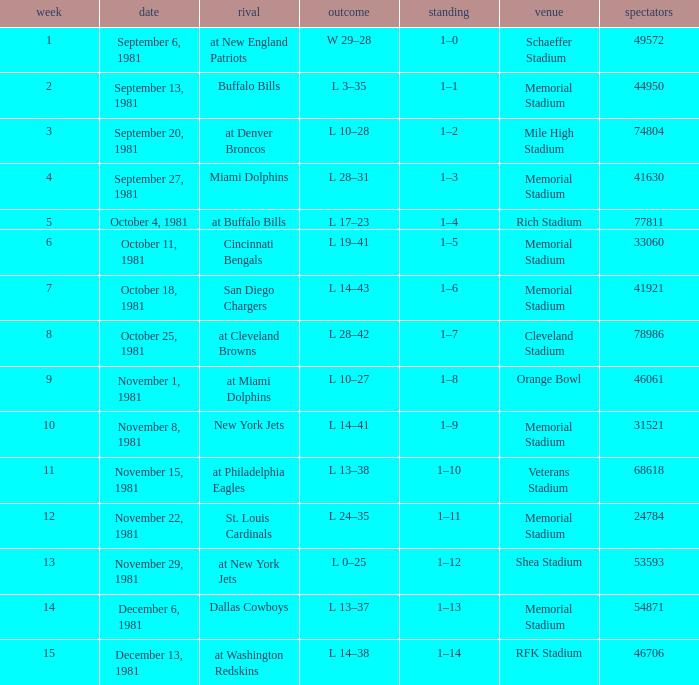When 74804 is the attendance what week is it? 3.0. 